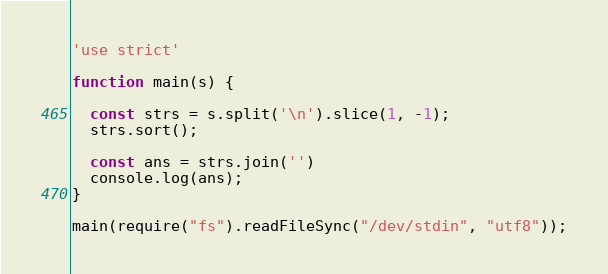<code> <loc_0><loc_0><loc_500><loc_500><_JavaScript_>'use strict'

function main(s) {

  const strs = s.split('\n').slice(1, -1);
  strs.sort();

  const ans = strs.join('')
  console.log(ans);
}

main(require("fs").readFileSync("/dev/stdin", "utf8"));
</code> 